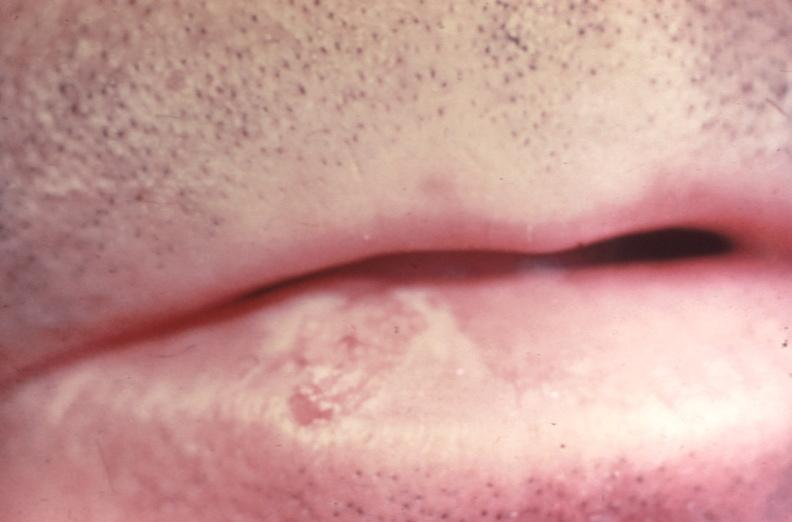what is present?
Answer the question using a single word or phrase. Gastrointestinal 